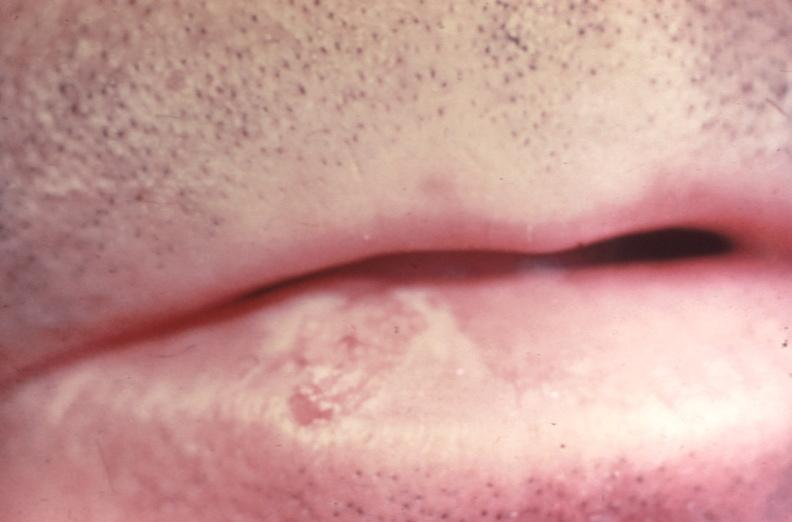what is present?
Answer the question using a single word or phrase. Gastrointestinal 